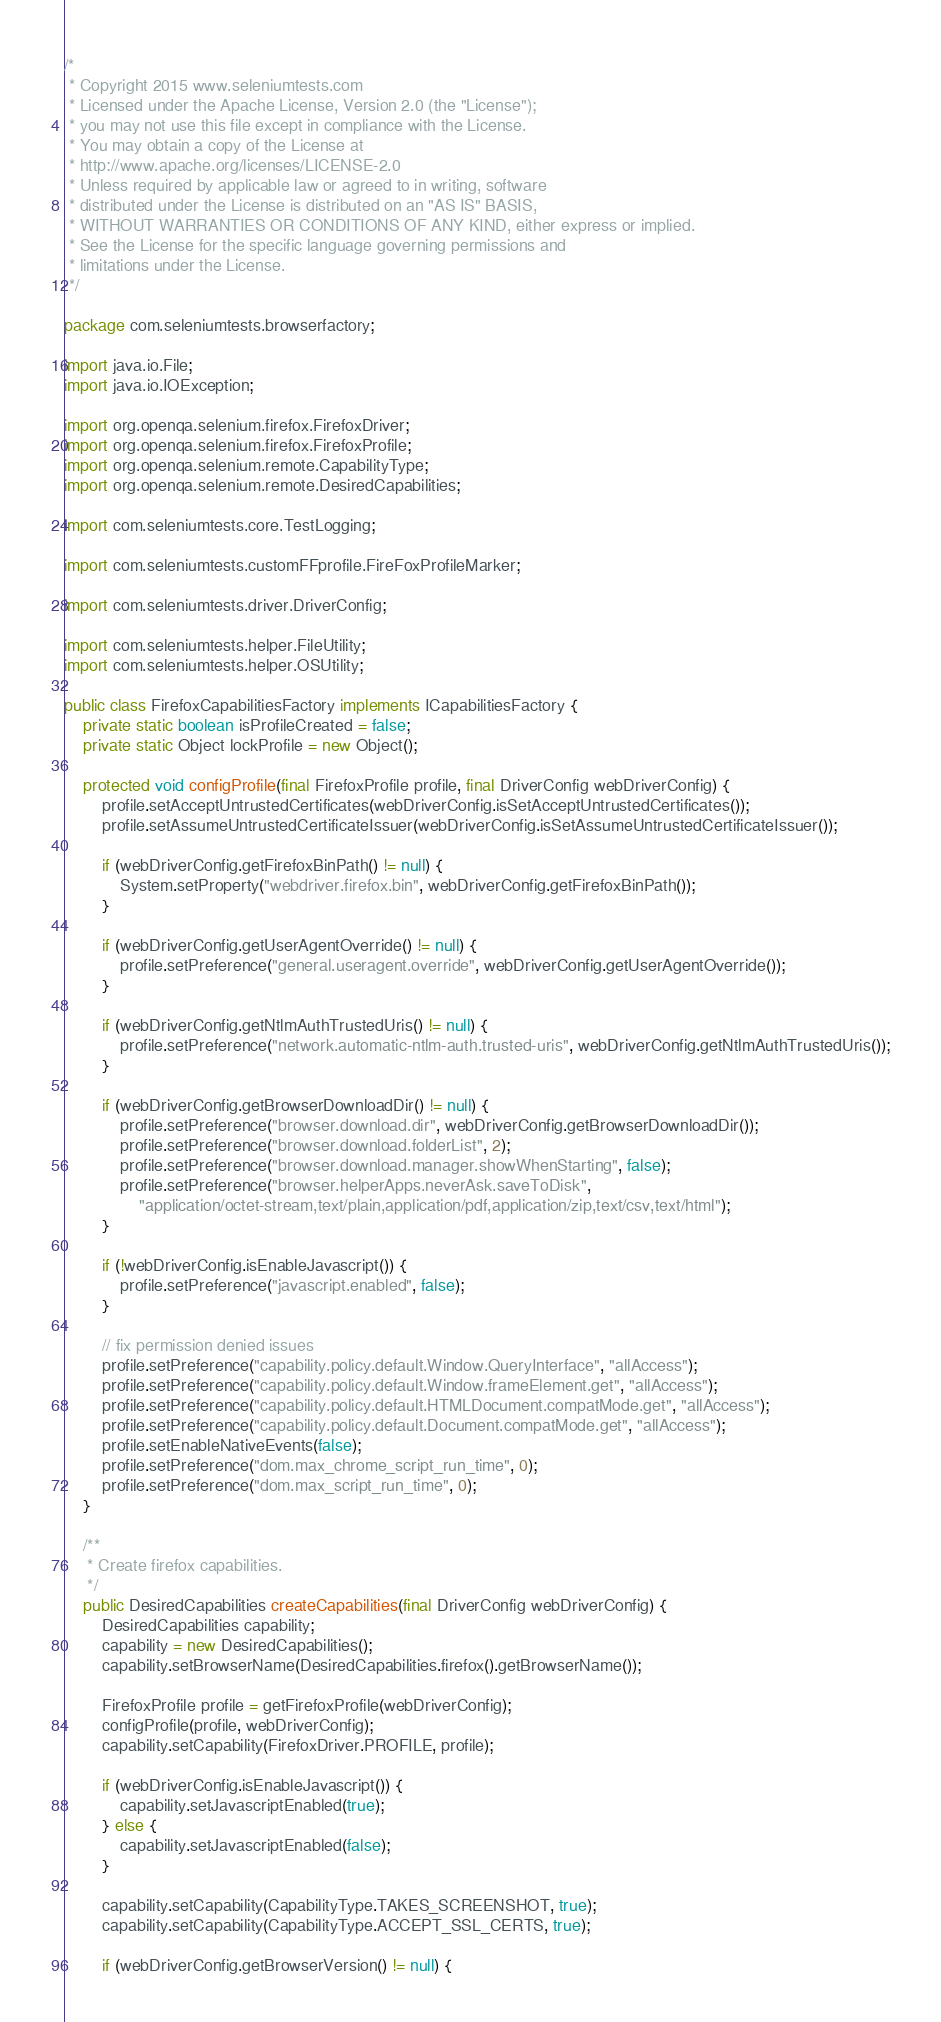<code> <loc_0><loc_0><loc_500><loc_500><_Java_>/*
 * Copyright 2015 www.seleniumtests.com
 * Licensed under the Apache License, Version 2.0 (the "License");
 * you may not use this file except in compliance with the License.
 * You may obtain a copy of the License at
 * http://www.apache.org/licenses/LICENSE-2.0
 * Unless required by applicable law or agreed to in writing, software
 * distributed under the License is distributed on an "AS IS" BASIS,
 * WITHOUT WARRANTIES OR CONDITIONS OF ANY KIND, either express or implied.
 * See the License for the specific language governing permissions and
 * limitations under the License.
 */

package com.seleniumtests.browserfactory;

import java.io.File;
import java.io.IOException;

import org.openqa.selenium.firefox.FirefoxDriver;
import org.openqa.selenium.firefox.FirefoxProfile;
import org.openqa.selenium.remote.CapabilityType;
import org.openqa.selenium.remote.DesiredCapabilities;

import com.seleniumtests.core.TestLogging;

import com.seleniumtests.customFFprofile.FireFoxProfileMarker;

import com.seleniumtests.driver.DriverConfig;

import com.seleniumtests.helper.FileUtility;
import com.seleniumtests.helper.OSUtility;

public class FirefoxCapabilitiesFactory implements ICapabilitiesFactory {
    private static boolean isProfileCreated = false;
    private static Object lockProfile = new Object();

    protected void configProfile(final FirefoxProfile profile, final DriverConfig webDriverConfig) {
        profile.setAcceptUntrustedCertificates(webDriverConfig.isSetAcceptUntrustedCertificates());
        profile.setAssumeUntrustedCertificateIssuer(webDriverConfig.isSetAssumeUntrustedCertificateIssuer());

        if (webDriverConfig.getFirefoxBinPath() != null) {
            System.setProperty("webdriver.firefox.bin", webDriverConfig.getFirefoxBinPath());
        }

        if (webDriverConfig.getUserAgentOverride() != null) {
            profile.setPreference("general.useragent.override", webDriverConfig.getUserAgentOverride());
        }

        if (webDriverConfig.getNtlmAuthTrustedUris() != null) {
            profile.setPreference("network.automatic-ntlm-auth.trusted-uris", webDriverConfig.getNtlmAuthTrustedUris());
        }

        if (webDriverConfig.getBrowserDownloadDir() != null) {
            profile.setPreference("browser.download.dir", webDriverConfig.getBrowserDownloadDir());
            profile.setPreference("browser.download.folderList", 2);
            profile.setPreference("browser.download.manager.showWhenStarting", false);
            profile.setPreference("browser.helperApps.neverAsk.saveToDisk",
                "application/octet-stream,text/plain,application/pdf,application/zip,text/csv,text/html");
        }

        if (!webDriverConfig.isEnableJavascript()) {
            profile.setPreference("javascript.enabled", false);
        }

        // fix permission denied issues
        profile.setPreference("capability.policy.default.Window.QueryInterface", "allAccess");
        profile.setPreference("capability.policy.default.Window.frameElement.get", "allAccess");
        profile.setPreference("capability.policy.default.HTMLDocument.compatMode.get", "allAccess");
        profile.setPreference("capability.policy.default.Document.compatMode.get", "allAccess");
        profile.setEnableNativeEvents(false);
        profile.setPreference("dom.max_chrome_script_run_time", 0);
        profile.setPreference("dom.max_script_run_time", 0);
    }

    /**
     * Create firefox capabilities.
     */
    public DesiredCapabilities createCapabilities(final DriverConfig webDriverConfig) {
        DesiredCapabilities capability;
        capability = new DesiredCapabilities();
        capability.setBrowserName(DesiredCapabilities.firefox().getBrowserName());

        FirefoxProfile profile = getFirefoxProfile(webDriverConfig);
        configProfile(profile, webDriverConfig);
        capability.setCapability(FirefoxDriver.PROFILE, profile);

        if (webDriverConfig.isEnableJavascript()) {
            capability.setJavascriptEnabled(true);
        } else {
            capability.setJavascriptEnabled(false);
        }

        capability.setCapability(CapabilityType.TAKES_SCREENSHOT, true);
        capability.setCapability(CapabilityType.ACCEPT_SSL_CERTS, true);

        if (webDriverConfig.getBrowserVersion() != null) {</code> 